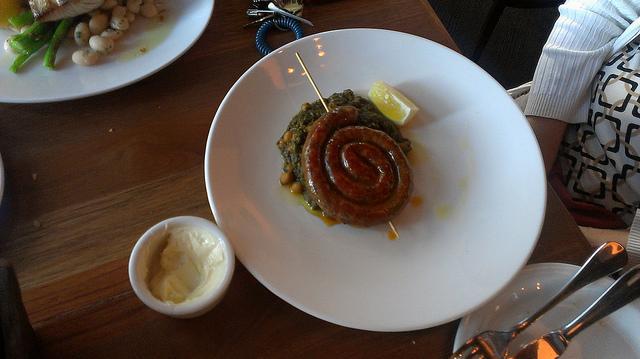What condiment is in the small white container next to the dish?

Choices:
A) mustard
B) blue cheese
C) ranch
D) butter butter 